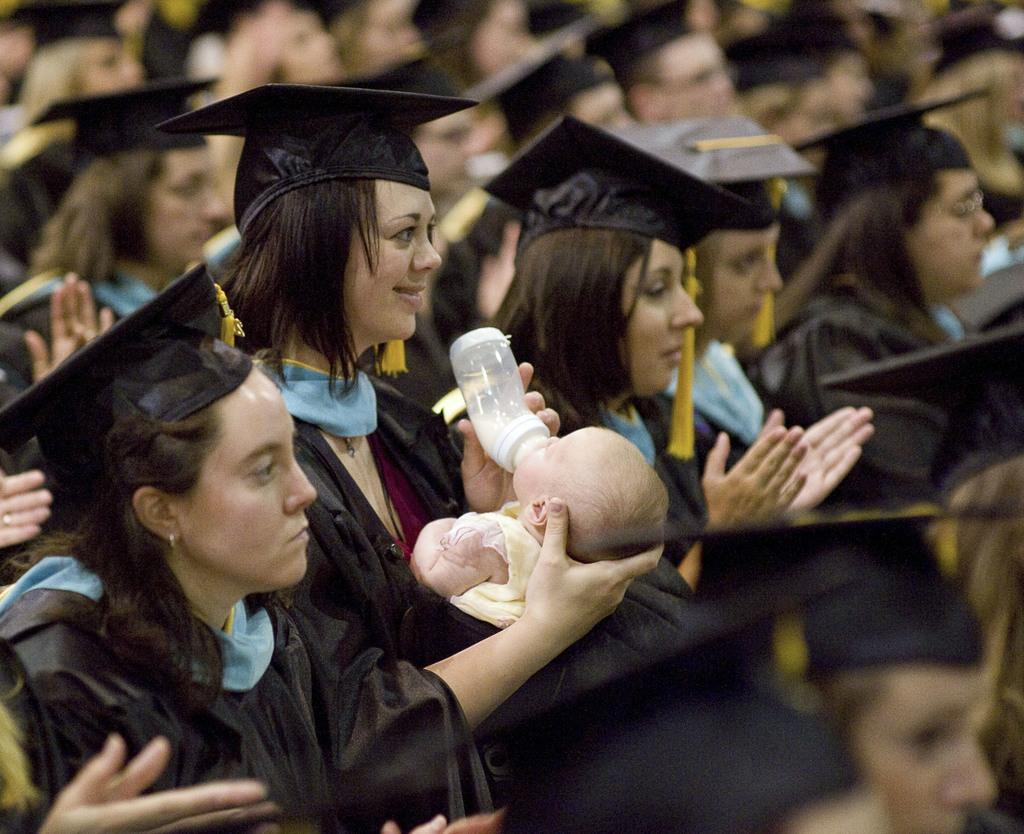What are the people in the image doing? There are people sitting in the image, and some of them are wearing hats. What activity is taking place in the image? There is hand clapping in the image. Can you describe a specific action being performed by someone in the image? A lady is feeding a baby in the image. What type of paper can be seen in the cemetery in the image? There is no paper or cemetery present in the image; it features people sitting, some wearing hats, with hand clapping and a lady feeding a baby. 